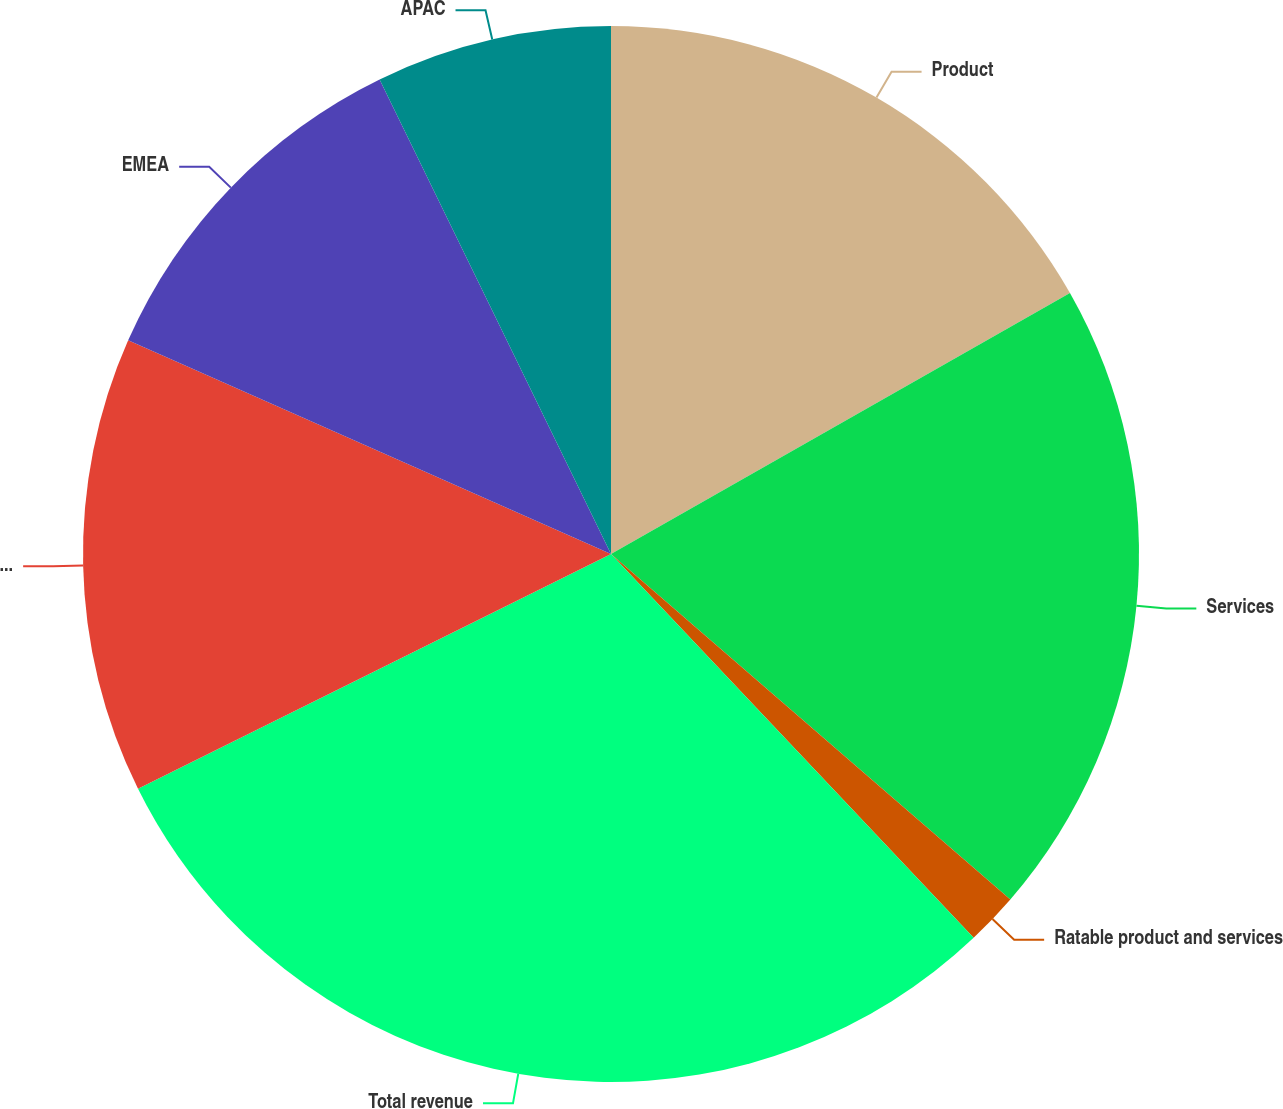<chart> <loc_0><loc_0><loc_500><loc_500><pie_chart><fcel>Product<fcel>Services<fcel>Ratable product and services<fcel>Total revenue<fcel>Americas<fcel>EMEA<fcel>APAC<nl><fcel>16.77%<fcel>19.58%<fcel>1.6%<fcel>29.72%<fcel>13.96%<fcel>11.15%<fcel>7.22%<nl></chart> 